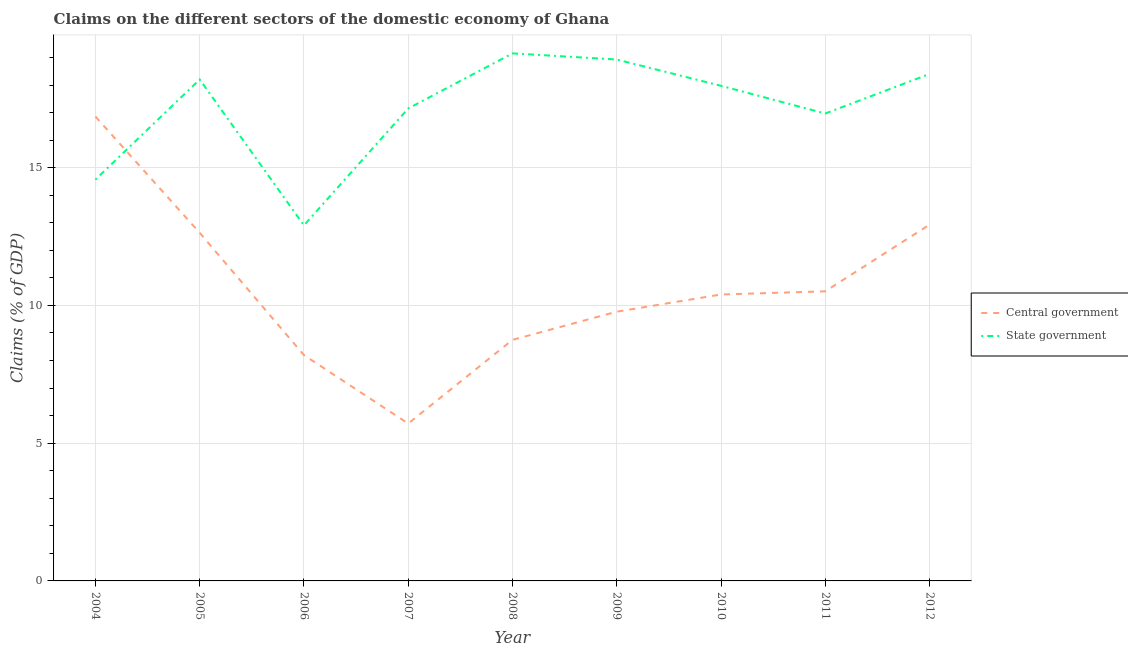How many different coloured lines are there?
Offer a very short reply. 2. Is the number of lines equal to the number of legend labels?
Ensure brevity in your answer.  Yes. What is the claims on state government in 2004?
Provide a succinct answer. 14.57. Across all years, what is the maximum claims on central government?
Offer a terse response. 16.86. Across all years, what is the minimum claims on central government?
Your response must be concise. 5.71. In which year was the claims on state government maximum?
Keep it short and to the point. 2008. In which year was the claims on central government minimum?
Offer a very short reply. 2007. What is the total claims on central government in the graph?
Keep it short and to the point. 95.77. What is the difference between the claims on central government in 2005 and that in 2011?
Your response must be concise. 2.12. What is the difference between the claims on state government in 2011 and the claims on central government in 2008?
Provide a succinct answer. 8.22. What is the average claims on central government per year?
Offer a terse response. 10.64. In the year 2010, what is the difference between the claims on state government and claims on central government?
Provide a short and direct response. 7.58. What is the ratio of the claims on state government in 2006 to that in 2010?
Offer a very short reply. 0.72. Is the claims on central government in 2009 less than that in 2012?
Provide a short and direct response. Yes. What is the difference between the highest and the second highest claims on state government?
Offer a terse response. 0.22. What is the difference between the highest and the lowest claims on central government?
Give a very brief answer. 11.15. Is the sum of the claims on state government in 2006 and 2009 greater than the maximum claims on central government across all years?
Make the answer very short. Yes. Does the claims on state government monotonically increase over the years?
Offer a very short reply. No. Is the claims on central government strictly greater than the claims on state government over the years?
Your answer should be very brief. No. How many lines are there?
Offer a very short reply. 2. How many years are there in the graph?
Your answer should be compact. 9. What is the difference between two consecutive major ticks on the Y-axis?
Your answer should be compact. 5. How are the legend labels stacked?
Your answer should be very brief. Vertical. What is the title of the graph?
Give a very brief answer. Claims on the different sectors of the domestic economy of Ghana. Does "Transport services" appear as one of the legend labels in the graph?
Your response must be concise. No. What is the label or title of the X-axis?
Keep it short and to the point. Year. What is the label or title of the Y-axis?
Provide a succinct answer. Claims (% of GDP). What is the Claims (% of GDP) of Central government in 2004?
Ensure brevity in your answer.  16.86. What is the Claims (% of GDP) in State government in 2004?
Offer a very short reply. 14.57. What is the Claims (% of GDP) of Central government in 2005?
Your answer should be compact. 12.64. What is the Claims (% of GDP) of State government in 2005?
Give a very brief answer. 18.2. What is the Claims (% of GDP) in Central government in 2006?
Offer a terse response. 8.2. What is the Claims (% of GDP) of State government in 2006?
Provide a short and direct response. 12.91. What is the Claims (% of GDP) in Central government in 2007?
Your answer should be compact. 5.71. What is the Claims (% of GDP) of State government in 2007?
Offer a very short reply. 17.15. What is the Claims (% of GDP) in Central government in 2008?
Offer a very short reply. 8.75. What is the Claims (% of GDP) in State government in 2008?
Make the answer very short. 19.15. What is the Claims (% of GDP) in Central government in 2009?
Provide a short and direct response. 9.77. What is the Claims (% of GDP) of State government in 2009?
Offer a very short reply. 18.93. What is the Claims (% of GDP) in Central government in 2010?
Make the answer very short. 10.4. What is the Claims (% of GDP) of State government in 2010?
Your response must be concise. 17.97. What is the Claims (% of GDP) in Central government in 2011?
Make the answer very short. 10.51. What is the Claims (% of GDP) in State government in 2011?
Provide a succinct answer. 16.97. What is the Claims (% of GDP) of Central government in 2012?
Your response must be concise. 12.93. What is the Claims (% of GDP) of State government in 2012?
Provide a short and direct response. 18.4. Across all years, what is the maximum Claims (% of GDP) of Central government?
Ensure brevity in your answer.  16.86. Across all years, what is the maximum Claims (% of GDP) of State government?
Provide a short and direct response. 19.15. Across all years, what is the minimum Claims (% of GDP) of Central government?
Offer a very short reply. 5.71. Across all years, what is the minimum Claims (% of GDP) of State government?
Make the answer very short. 12.91. What is the total Claims (% of GDP) in Central government in the graph?
Offer a terse response. 95.77. What is the total Claims (% of GDP) in State government in the graph?
Provide a short and direct response. 154.25. What is the difference between the Claims (% of GDP) of Central government in 2004 and that in 2005?
Ensure brevity in your answer.  4.22. What is the difference between the Claims (% of GDP) of State government in 2004 and that in 2005?
Keep it short and to the point. -3.63. What is the difference between the Claims (% of GDP) of Central government in 2004 and that in 2006?
Your response must be concise. 8.66. What is the difference between the Claims (% of GDP) of State government in 2004 and that in 2006?
Provide a succinct answer. 1.66. What is the difference between the Claims (% of GDP) in Central government in 2004 and that in 2007?
Provide a short and direct response. 11.15. What is the difference between the Claims (% of GDP) of State government in 2004 and that in 2007?
Keep it short and to the point. -2.58. What is the difference between the Claims (% of GDP) of Central government in 2004 and that in 2008?
Provide a succinct answer. 8.11. What is the difference between the Claims (% of GDP) of State government in 2004 and that in 2008?
Provide a short and direct response. -4.58. What is the difference between the Claims (% of GDP) in Central government in 2004 and that in 2009?
Make the answer very short. 7.08. What is the difference between the Claims (% of GDP) in State government in 2004 and that in 2009?
Make the answer very short. -4.36. What is the difference between the Claims (% of GDP) in Central government in 2004 and that in 2010?
Provide a short and direct response. 6.46. What is the difference between the Claims (% of GDP) in State government in 2004 and that in 2010?
Ensure brevity in your answer.  -3.4. What is the difference between the Claims (% of GDP) in Central government in 2004 and that in 2011?
Your answer should be very brief. 6.34. What is the difference between the Claims (% of GDP) in State government in 2004 and that in 2011?
Give a very brief answer. -2.4. What is the difference between the Claims (% of GDP) of Central government in 2004 and that in 2012?
Offer a very short reply. 3.92. What is the difference between the Claims (% of GDP) in State government in 2004 and that in 2012?
Your response must be concise. -3.83. What is the difference between the Claims (% of GDP) in Central government in 2005 and that in 2006?
Provide a short and direct response. 4.44. What is the difference between the Claims (% of GDP) of State government in 2005 and that in 2006?
Offer a terse response. 5.3. What is the difference between the Claims (% of GDP) in Central government in 2005 and that in 2007?
Provide a succinct answer. 6.92. What is the difference between the Claims (% of GDP) in State government in 2005 and that in 2007?
Ensure brevity in your answer.  1.05. What is the difference between the Claims (% of GDP) in Central government in 2005 and that in 2008?
Provide a succinct answer. 3.89. What is the difference between the Claims (% of GDP) in State government in 2005 and that in 2008?
Your response must be concise. -0.95. What is the difference between the Claims (% of GDP) in Central government in 2005 and that in 2009?
Your answer should be very brief. 2.86. What is the difference between the Claims (% of GDP) of State government in 2005 and that in 2009?
Provide a short and direct response. -0.72. What is the difference between the Claims (% of GDP) of Central government in 2005 and that in 2010?
Keep it short and to the point. 2.24. What is the difference between the Claims (% of GDP) in State government in 2005 and that in 2010?
Your answer should be very brief. 0.23. What is the difference between the Claims (% of GDP) of Central government in 2005 and that in 2011?
Your response must be concise. 2.12. What is the difference between the Claims (% of GDP) in State government in 2005 and that in 2011?
Give a very brief answer. 1.24. What is the difference between the Claims (% of GDP) of Central government in 2005 and that in 2012?
Ensure brevity in your answer.  -0.3. What is the difference between the Claims (% of GDP) of State government in 2005 and that in 2012?
Keep it short and to the point. -0.2. What is the difference between the Claims (% of GDP) in Central government in 2006 and that in 2007?
Ensure brevity in your answer.  2.48. What is the difference between the Claims (% of GDP) in State government in 2006 and that in 2007?
Keep it short and to the point. -4.24. What is the difference between the Claims (% of GDP) of Central government in 2006 and that in 2008?
Provide a succinct answer. -0.55. What is the difference between the Claims (% of GDP) in State government in 2006 and that in 2008?
Your answer should be very brief. -6.24. What is the difference between the Claims (% of GDP) in Central government in 2006 and that in 2009?
Provide a short and direct response. -1.58. What is the difference between the Claims (% of GDP) of State government in 2006 and that in 2009?
Offer a very short reply. -6.02. What is the difference between the Claims (% of GDP) of Central government in 2006 and that in 2010?
Your answer should be very brief. -2.2. What is the difference between the Claims (% of GDP) of State government in 2006 and that in 2010?
Offer a terse response. -5.07. What is the difference between the Claims (% of GDP) of Central government in 2006 and that in 2011?
Provide a short and direct response. -2.32. What is the difference between the Claims (% of GDP) of State government in 2006 and that in 2011?
Ensure brevity in your answer.  -4.06. What is the difference between the Claims (% of GDP) in Central government in 2006 and that in 2012?
Provide a succinct answer. -4.74. What is the difference between the Claims (% of GDP) in State government in 2006 and that in 2012?
Offer a very short reply. -5.5. What is the difference between the Claims (% of GDP) in Central government in 2007 and that in 2008?
Make the answer very short. -3.04. What is the difference between the Claims (% of GDP) of State government in 2007 and that in 2008?
Your answer should be very brief. -2. What is the difference between the Claims (% of GDP) in Central government in 2007 and that in 2009?
Provide a succinct answer. -4.06. What is the difference between the Claims (% of GDP) in State government in 2007 and that in 2009?
Offer a very short reply. -1.78. What is the difference between the Claims (% of GDP) of Central government in 2007 and that in 2010?
Your response must be concise. -4.69. What is the difference between the Claims (% of GDP) of State government in 2007 and that in 2010?
Ensure brevity in your answer.  -0.82. What is the difference between the Claims (% of GDP) of Central government in 2007 and that in 2011?
Your answer should be compact. -4.8. What is the difference between the Claims (% of GDP) of State government in 2007 and that in 2011?
Offer a very short reply. 0.18. What is the difference between the Claims (% of GDP) of Central government in 2007 and that in 2012?
Ensure brevity in your answer.  -7.22. What is the difference between the Claims (% of GDP) of State government in 2007 and that in 2012?
Offer a terse response. -1.25. What is the difference between the Claims (% of GDP) in Central government in 2008 and that in 2009?
Give a very brief answer. -1.02. What is the difference between the Claims (% of GDP) in State government in 2008 and that in 2009?
Your answer should be compact. 0.22. What is the difference between the Claims (% of GDP) in Central government in 2008 and that in 2010?
Your answer should be very brief. -1.65. What is the difference between the Claims (% of GDP) in State government in 2008 and that in 2010?
Your answer should be very brief. 1.18. What is the difference between the Claims (% of GDP) of Central government in 2008 and that in 2011?
Provide a short and direct response. -1.76. What is the difference between the Claims (% of GDP) of State government in 2008 and that in 2011?
Make the answer very short. 2.18. What is the difference between the Claims (% of GDP) in Central government in 2008 and that in 2012?
Keep it short and to the point. -4.18. What is the difference between the Claims (% of GDP) in State government in 2008 and that in 2012?
Offer a very short reply. 0.75. What is the difference between the Claims (% of GDP) in Central government in 2009 and that in 2010?
Ensure brevity in your answer.  -0.62. What is the difference between the Claims (% of GDP) in State government in 2009 and that in 2010?
Your answer should be very brief. 0.95. What is the difference between the Claims (% of GDP) of Central government in 2009 and that in 2011?
Your answer should be compact. -0.74. What is the difference between the Claims (% of GDP) of State government in 2009 and that in 2011?
Offer a very short reply. 1.96. What is the difference between the Claims (% of GDP) of Central government in 2009 and that in 2012?
Your response must be concise. -3.16. What is the difference between the Claims (% of GDP) in State government in 2009 and that in 2012?
Make the answer very short. 0.52. What is the difference between the Claims (% of GDP) of Central government in 2010 and that in 2011?
Offer a very short reply. -0.12. What is the difference between the Claims (% of GDP) in Central government in 2010 and that in 2012?
Keep it short and to the point. -2.54. What is the difference between the Claims (% of GDP) of State government in 2010 and that in 2012?
Offer a terse response. -0.43. What is the difference between the Claims (% of GDP) in Central government in 2011 and that in 2012?
Ensure brevity in your answer.  -2.42. What is the difference between the Claims (% of GDP) in State government in 2011 and that in 2012?
Offer a very short reply. -1.44. What is the difference between the Claims (% of GDP) of Central government in 2004 and the Claims (% of GDP) of State government in 2005?
Offer a very short reply. -1.35. What is the difference between the Claims (% of GDP) of Central government in 2004 and the Claims (% of GDP) of State government in 2006?
Ensure brevity in your answer.  3.95. What is the difference between the Claims (% of GDP) in Central government in 2004 and the Claims (% of GDP) in State government in 2007?
Your response must be concise. -0.29. What is the difference between the Claims (% of GDP) of Central government in 2004 and the Claims (% of GDP) of State government in 2008?
Your answer should be very brief. -2.29. What is the difference between the Claims (% of GDP) of Central government in 2004 and the Claims (% of GDP) of State government in 2009?
Make the answer very short. -2.07. What is the difference between the Claims (% of GDP) in Central government in 2004 and the Claims (% of GDP) in State government in 2010?
Give a very brief answer. -1.12. What is the difference between the Claims (% of GDP) in Central government in 2004 and the Claims (% of GDP) in State government in 2011?
Provide a short and direct response. -0.11. What is the difference between the Claims (% of GDP) in Central government in 2004 and the Claims (% of GDP) in State government in 2012?
Your response must be concise. -1.55. What is the difference between the Claims (% of GDP) in Central government in 2005 and the Claims (% of GDP) in State government in 2006?
Offer a terse response. -0.27. What is the difference between the Claims (% of GDP) in Central government in 2005 and the Claims (% of GDP) in State government in 2007?
Provide a short and direct response. -4.51. What is the difference between the Claims (% of GDP) in Central government in 2005 and the Claims (% of GDP) in State government in 2008?
Give a very brief answer. -6.51. What is the difference between the Claims (% of GDP) in Central government in 2005 and the Claims (% of GDP) in State government in 2009?
Keep it short and to the point. -6.29. What is the difference between the Claims (% of GDP) in Central government in 2005 and the Claims (% of GDP) in State government in 2010?
Your answer should be compact. -5.34. What is the difference between the Claims (% of GDP) in Central government in 2005 and the Claims (% of GDP) in State government in 2011?
Your answer should be compact. -4.33. What is the difference between the Claims (% of GDP) of Central government in 2005 and the Claims (% of GDP) of State government in 2012?
Your answer should be very brief. -5.77. What is the difference between the Claims (% of GDP) in Central government in 2006 and the Claims (% of GDP) in State government in 2007?
Ensure brevity in your answer.  -8.95. What is the difference between the Claims (% of GDP) of Central government in 2006 and the Claims (% of GDP) of State government in 2008?
Keep it short and to the point. -10.95. What is the difference between the Claims (% of GDP) in Central government in 2006 and the Claims (% of GDP) in State government in 2009?
Your response must be concise. -10.73. What is the difference between the Claims (% of GDP) in Central government in 2006 and the Claims (% of GDP) in State government in 2010?
Make the answer very short. -9.78. What is the difference between the Claims (% of GDP) in Central government in 2006 and the Claims (% of GDP) in State government in 2011?
Offer a very short reply. -8.77. What is the difference between the Claims (% of GDP) of Central government in 2006 and the Claims (% of GDP) of State government in 2012?
Ensure brevity in your answer.  -10.21. What is the difference between the Claims (% of GDP) of Central government in 2007 and the Claims (% of GDP) of State government in 2008?
Keep it short and to the point. -13.44. What is the difference between the Claims (% of GDP) in Central government in 2007 and the Claims (% of GDP) in State government in 2009?
Make the answer very short. -13.21. What is the difference between the Claims (% of GDP) in Central government in 2007 and the Claims (% of GDP) in State government in 2010?
Your response must be concise. -12.26. What is the difference between the Claims (% of GDP) of Central government in 2007 and the Claims (% of GDP) of State government in 2011?
Ensure brevity in your answer.  -11.25. What is the difference between the Claims (% of GDP) in Central government in 2007 and the Claims (% of GDP) in State government in 2012?
Make the answer very short. -12.69. What is the difference between the Claims (% of GDP) in Central government in 2008 and the Claims (% of GDP) in State government in 2009?
Ensure brevity in your answer.  -10.18. What is the difference between the Claims (% of GDP) of Central government in 2008 and the Claims (% of GDP) of State government in 2010?
Your response must be concise. -9.22. What is the difference between the Claims (% of GDP) of Central government in 2008 and the Claims (% of GDP) of State government in 2011?
Make the answer very short. -8.22. What is the difference between the Claims (% of GDP) of Central government in 2008 and the Claims (% of GDP) of State government in 2012?
Provide a short and direct response. -9.65. What is the difference between the Claims (% of GDP) in Central government in 2009 and the Claims (% of GDP) in State government in 2010?
Provide a short and direct response. -8.2. What is the difference between the Claims (% of GDP) of Central government in 2009 and the Claims (% of GDP) of State government in 2011?
Your answer should be very brief. -7.19. What is the difference between the Claims (% of GDP) in Central government in 2009 and the Claims (% of GDP) in State government in 2012?
Ensure brevity in your answer.  -8.63. What is the difference between the Claims (% of GDP) in Central government in 2010 and the Claims (% of GDP) in State government in 2011?
Give a very brief answer. -6.57. What is the difference between the Claims (% of GDP) in Central government in 2010 and the Claims (% of GDP) in State government in 2012?
Give a very brief answer. -8.01. What is the difference between the Claims (% of GDP) in Central government in 2011 and the Claims (% of GDP) in State government in 2012?
Keep it short and to the point. -7.89. What is the average Claims (% of GDP) in Central government per year?
Your answer should be compact. 10.64. What is the average Claims (% of GDP) of State government per year?
Your response must be concise. 17.14. In the year 2004, what is the difference between the Claims (% of GDP) in Central government and Claims (% of GDP) in State government?
Give a very brief answer. 2.29. In the year 2005, what is the difference between the Claims (% of GDP) of Central government and Claims (% of GDP) of State government?
Your response must be concise. -5.57. In the year 2006, what is the difference between the Claims (% of GDP) in Central government and Claims (% of GDP) in State government?
Offer a very short reply. -4.71. In the year 2007, what is the difference between the Claims (% of GDP) of Central government and Claims (% of GDP) of State government?
Offer a terse response. -11.44. In the year 2008, what is the difference between the Claims (% of GDP) of Central government and Claims (% of GDP) of State government?
Give a very brief answer. -10.4. In the year 2009, what is the difference between the Claims (% of GDP) of Central government and Claims (% of GDP) of State government?
Your answer should be very brief. -9.15. In the year 2010, what is the difference between the Claims (% of GDP) of Central government and Claims (% of GDP) of State government?
Your answer should be very brief. -7.58. In the year 2011, what is the difference between the Claims (% of GDP) in Central government and Claims (% of GDP) in State government?
Offer a very short reply. -6.45. In the year 2012, what is the difference between the Claims (% of GDP) in Central government and Claims (% of GDP) in State government?
Ensure brevity in your answer.  -5.47. What is the ratio of the Claims (% of GDP) of Central government in 2004 to that in 2005?
Provide a succinct answer. 1.33. What is the ratio of the Claims (% of GDP) in State government in 2004 to that in 2005?
Your response must be concise. 0.8. What is the ratio of the Claims (% of GDP) in Central government in 2004 to that in 2006?
Your answer should be very brief. 2.06. What is the ratio of the Claims (% of GDP) in State government in 2004 to that in 2006?
Give a very brief answer. 1.13. What is the ratio of the Claims (% of GDP) in Central government in 2004 to that in 2007?
Make the answer very short. 2.95. What is the ratio of the Claims (% of GDP) of State government in 2004 to that in 2007?
Offer a terse response. 0.85. What is the ratio of the Claims (% of GDP) of Central government in 2004 to that in 2008?
Keep it short and to the point. 1.93. What is the ratio of the Claims (% of GDP) of State government in 2004 to that in 2008?
Provide a succinct answer. 0.76. What is the ratio of the Claims (% of GDP) of Central government in 2004 to that in 2009?
Provide a short and direct response. 1.72. What is the ratio of the Claims (% of GDP) in State government in 2004 to that in 2009?
Your answer should be compact. 0.77. What is the ratio of the Claims (% of GDP) in Central government in 2004 to that in 2010?
Offer a very short reply. 1.62. What is the ratio of the Claims (% of GDP) of State government in 2004 to that in 2010?
Provide a short and direct response. 0.81. What is the ratio of the Claims (% of GDP) in Central government in 2004 to that in 2011?
Your answer should be very brief. 1.6. What is the ratio of the Claims (% of GDP) in State government in 2004 to that in 2011?
Provide a succinct answer. 0.86. What is the ratio of the Claims (% of GDP) in Central government in 2004 to that in 2012?
Your answer should be compact. 1.3. What is the ratio of the Claims (% of GDP) of State government in 2004 to that in 2012?
Make the answer very short. 0.79. What is the ratio of the Claims (% of GDP) in Central government in 2005 to that in 2006?
Provide a short and direct response. 1.54. What is the ratio of the Claims (% of GDP) in State government in 2005 to that in 2006?
Your response must be concise. 1.41. What is the ratio of the Claims (% of GDP) of Central government in 2005 to that in 2007?
Your response must be concise. 2.21. What is the ratio of the Claims (% of GDP) of State government in 2005 to that in 2007?
Make the answer very short. 1.06. What is the ratio of the Claims (% of GDP) of Central government in 2005 to that in 2008?
Give a very brief answer. 1.44. What is the ratio of the Claims (% of GDP) in State government in 2005 to that in 2008?
Give a very brief answer. 0.95. What is the ratio of the Claims (% of GDP) in Central government in 2005 to that in 2009?
Give a very brief answer. 1.29. What is the ratio of the Claims (% of GDP) of State government in 2005 to that in 2009?
Ensure brevity in your answer.  0.96. What is the ratio of the Claims (% of GDP) of Central government in 2005 to that in 2010?
Offer a very short reply. 1.22. What is the ratio of the Claims (% of GDP) of State government in 2005 to that in 2010?
Make the answer very short. 1.01. What is the ratio of the Claims (% of GDP) of Central government in 2005 to that in 2011?
Give a very brief answer. 1.2. What is the ratio of the Claims (% of GDP) in State government in 2005 to that in 2011?
Provide a short and direct response. 1.07. What is the ratio of the Claims (% of GDP) in Central government in 2005 to that in 2012?
Your response must be concise. 0.98. What is the ratio of the Claims (% of GDP) of State government in 2005 to that in 2012?
Give a very brief answer. 0.99. What is the ratio of the Claims (% of GDP) of Central government in 2006 to that in 2007?
Ensure brevity in your answer.  1.44. What is the ratio of the Claims (% of GDP) of State government in 2006 to that in 2007?
Keep it short and to the point. 0.75. What is the ratio of the Claims (% of GDP) in Central government in 2006 to that in 2008?
Ensure brevity in your answer.  0.94. What is the ratio of the Claims (% of GDP) in State government in 2006 to that in 2008?
Offer a very short reply. 0.67. What is the ratio of the Claims (% of GDP) of Central government in 2006 to that in 2009?
Offer a very short reply. 0.84. What is the ratio of the Claims (% of GDP) of State government in 2006 to that in 2009?
Provide a short and direct response. 0.68. What is the ratio of the Claims (% of GDP) of Central government in 2006 to that in 2010?
Make the answer very short. 0.79. What is the ratio of the Claims (% of GDP) of State government in 2006 to that in 2010?
Ensure brevity in your answer.  0.72. What is the ratio of the Claims (% of GDP) of Central government in 2006 to that in 2011?
Make the answer very short. 0.78. What is the ratio of the Claims (% of GDP) in State government in 2006 to that in 2011?
Offer a very short reply. 0.76. What is the ratio of the Claims (% of GDP) in Central government in 2006 to that in 2012?
Keep it short and to the point. 0.63. What is the ratio of the Claims (% of GDP) of State government in 2006 to that in 2012?
Give a very brief answer. 0.7. What is the ratio of the Claims (% of GDP) in Central government in 2007 to that in 2008?
Provide a short and direct response. 0.65. What is the ratio of the Claims (% of GDP) in State government in 2007 to that in 2008?
Your answer should be compact. 0.9. What is the ratio of the Claims (% of GDP) in Central government in 2007 to that in 2009?
Give a very brief answer. 0.58. What is the ratio of the Claims (% of GDP) of State government in 2007 to that in 2009?
Make the answer very short. 0.91. What is the ratio of the Claims (% of GDP) of Central government in 2007 to that in 2010?
Your response must be concise. 0.55. What is the ratio of the Claims (% of GDP) in State government in 2007 to that in 2010?
Your answer should be very brief. 0.95. What is the ratio of the Claims (% of GDP) in Central government in 2007 to that in 2011?
Your answer should be compact. 0.54. What is the ratio of the Claims (% of GDP) in State government in 2007 to that in 2011?
Ensure brevity in your answer.  1.01. What is the ratio of the Claims (% of GDP) in Central government in 2007 to that in 2012?
Provide a short and direct response. 0.44. What is the ratio of the Claims (% of GDP) of State government in 2007 to that in 2012?
Provide a succinct answer. 0.93. What is the ratio of the Claims (% of GDP) of Central government in 2008 to that in 2009?
Ensure brevity in your answer.  0.9. What is the ratio of the Claims (% of GDP) of State government in 2008 to that in 2009?
Your response must be concise. 1.01. What is the ratio of the Claims (% of GDP) in Central government in 2008 to that in 2010?
Provide a succinct answer. 0.84. What is the ratio of the Claims (% of GDP) in State government in 2008 to that in 2010?
Keep it short and to the point. 1.07. What is the ratio of the Claims (% of GDP) of Central government in 2008 to that in 2011?
Provide a succinct answer. 0.83. What is the ratio of the Claims (% of GDP) of State government in 2008 to that in 2011?
Keep it short and to the point. 1.13. What is the ratio of the Claims (% of GDP) of Central government in 2008 to that in 2012?
Your answer should be very brief. 0.68. What is the ratio of the Claims (% of GDP) in State government in 2008 to that in 2012?
Provide a succinct answer. 1.04. What is the ratio of the Claims (% of GDP) of Central government in 2009 to that in 2010?
Your answer should be compact. 0.94. What is the ratio of the Claims (% of GDP) of State government in 2009 to that in 2010?
Keep it short and to the point. 1.05. What is the ratio of the Claims (% of GDP) of Central government in 2009 to that in 2011?
Your answer should be compact. 0.93. What is the ratio of the Claims (% of GDP) of State government in 2009 to that in 2011?
Provide a short and direct response. 1.12. What is the ratio of the Claims (% of GDP) in Central government in 2009 to that in 2012?
Provide a succinct answer. 0.76. What is the ratio of the Claims (% of GDP) of State government in 2009 to that in 2012?
Your response must be concise. 1.03. What is the ratio of the Claims (% of GDP) of State government in 2010 to that in 2011?
Provide a short and direct response. 1.06. What is the ratio of the Claims (% of GDP) in Central government in 2010 to that in 2012?
Offer a very short reply. 0.8. What is the ratio of the Claims (% of GDP) of State government in 2010 to that in 2012?
Ensure brevity in your answer.  0.98. What is the ratio of the Claims (% of GDP) of Central government in 2011 to that in 2012?
Your answer should be very brief. 0.81. What is the ratio of the Claims (% of GDP) in State government in 2011 to that in 2012?
Keep it short and to the point. 0.92. What is the difference between the highest and the second highest Claims (% of GDP) of Central government?
Ensure brevity in your answer.  3.92. What is the difference between the highest and the second highest Claims (% of GDP) of State government?
Your answer should be very brief. 0.22. What is the difference between the highest and the lowest Claims (% of GDP) of Central government?
Your answer should be compact. 11.15. What is the difference between the highest and the lowest Claims (% of GDP) of State government?
Provide a short and direct response. 6.24. 